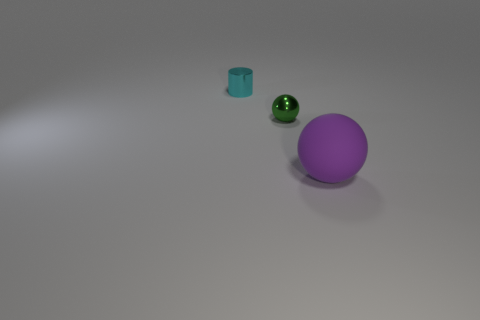Add 1 cyan metallic things. How many objects exist? 4 Subtract 1 spheres. How many spheres are left? 1 Add 1 large balls. How many large balls are left? 2 Add 2 big yellow matte balls. How many big yellow matte balls exist? 2 Subtract 0 red cubes. How many objects are left? 3 Subtract all cylinders. How many objects are left? 2 Subtract all blue cylinders. Subtract all green blocks. How many cylinders are left? 1 Subtract all small metallic objects. Subtract all tiny brown rubber cubes. How many objects are left? 1 